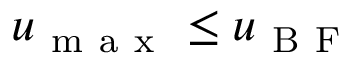<formula> <loc_0><loc_0><loc_500><loc_500>u _ { m a x } \leq u _ { B F }</formula> 